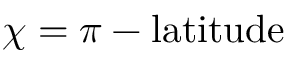<formula> <loc_0><loc_0><loc_500><loc_500>\chi = \pi - l a t i t u d e</formula> 